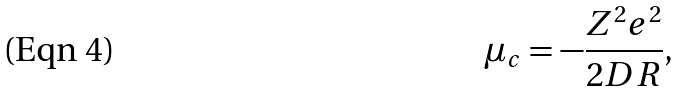Convert formula to latex. <formula><loc_0><loc_0><loc_500><loc_500>\mu _ { c } = - \frac { Z ^ { 2 } e ^ { 2 } } { 2 D R } ,</formula> 